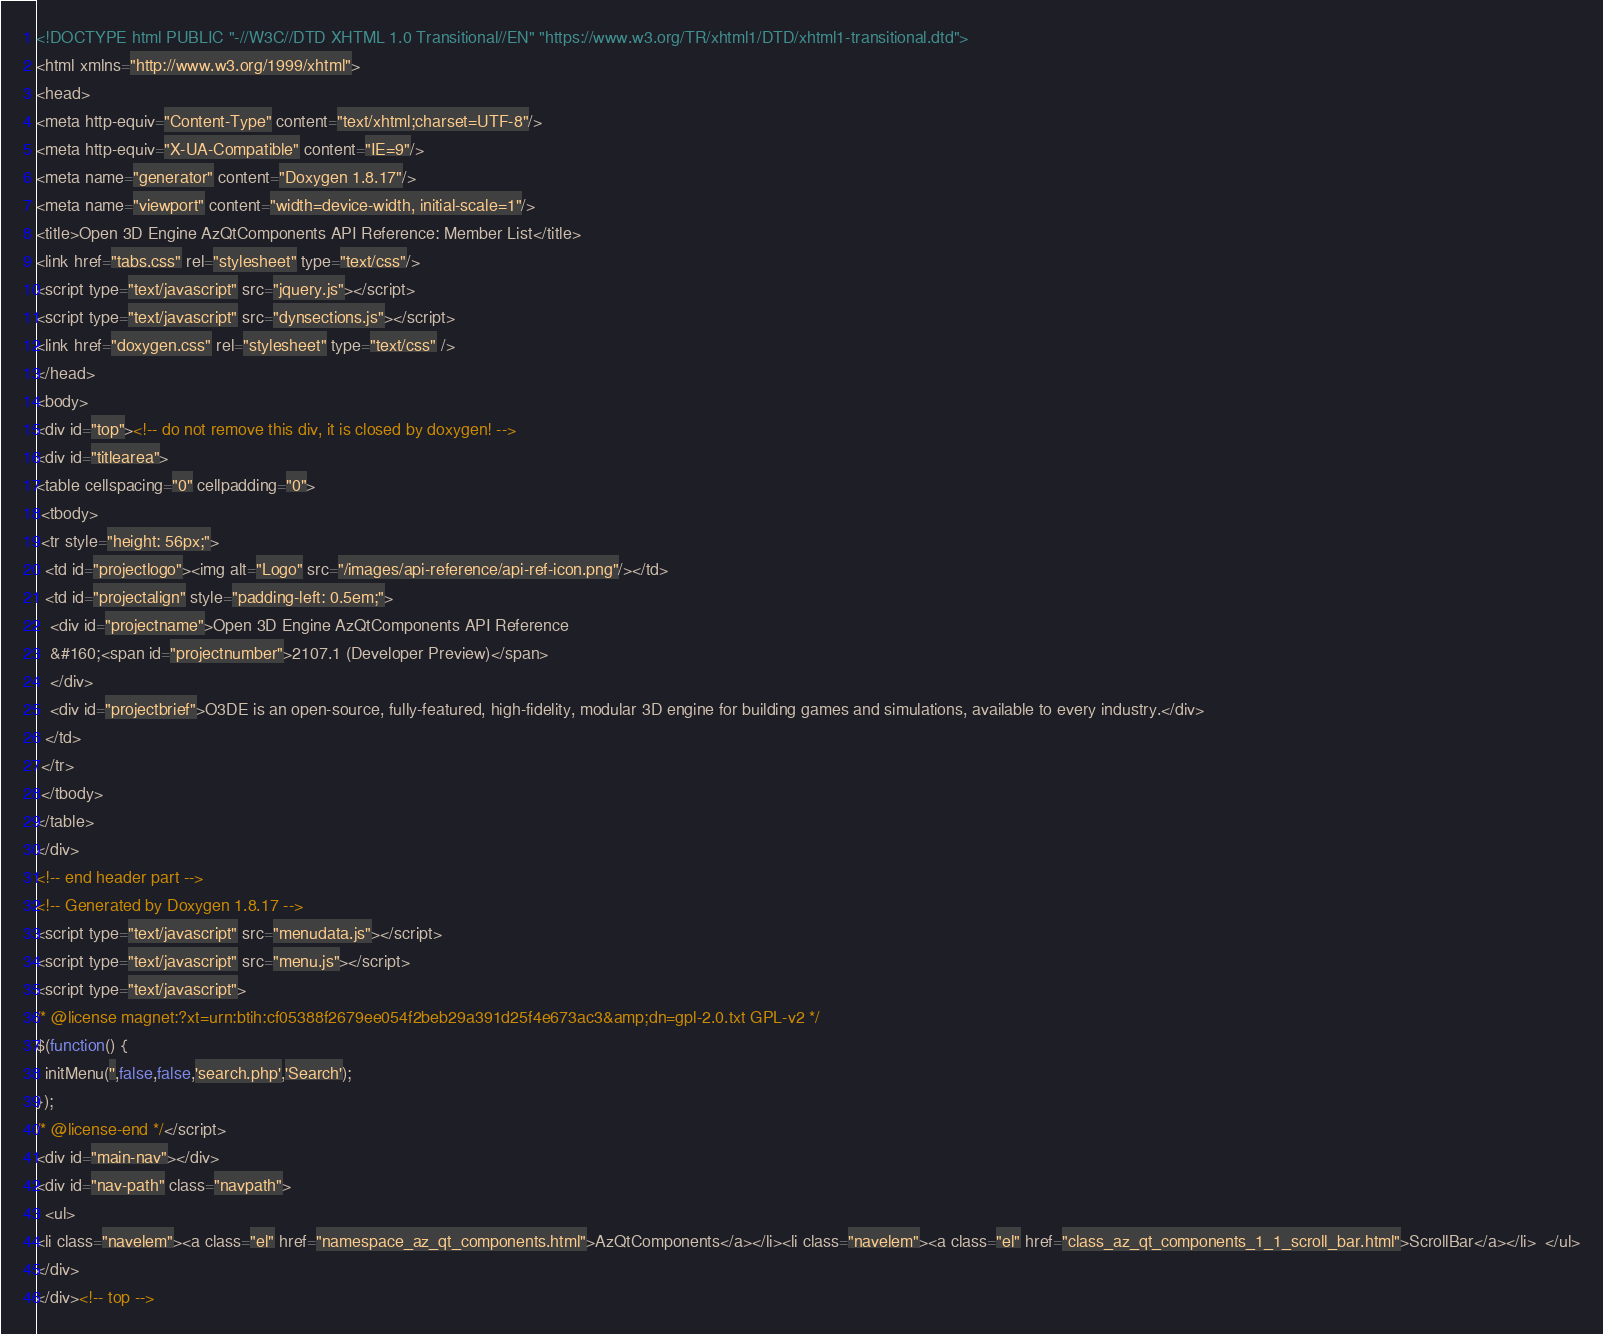<code> <loc_0><loc_0><loc_500><loc_500><_HTML_><!DOCTYPE html PUBLIC "-//W3C//DTD XHTML 1.0 Transitional//EN" "https://www.w3.org/TR/xhtml1/DTD/xhtml1-transitional.dtd">
<html xmlns="http://www.w3.org/1999/xhtml">
<head>
<meta http-equiv="Content-Type" content="text/xhtml;charset=UTF-8"/>
<meta http-equiv="X-UA-Compatible" content="IE=9"/>
<meta name="generator" content="Doxygen 1.8.17"/>
<meta name="viewport" content="width=device-width, initial-scale=1"/>
<title>Open 3D Engine AzQtComponents API Reference: Member List</title>
<link href="tabs.css" rel="stylesheet" type="text/css"/>
<script type="text/javascript" src="jquery.js"></script>
<script type="text/javascript" src="dynsections.js"></script>
<link href="doxygen.css" rel="stylesheet" type="text/css" />
</head>
<body>
<div id="top"><!-- do not remove this div, it is closed by doxygen! -->
<div id="titlearea">
<table cellspacing="0" cellpadding="0">
 <tbody>
 <tr style="height: 56px;">
  <td id="projectlogo"><img alt="Logo" src="/images/api-reference/api-ref-icon.png"/></td>
  <td id="projectalign" style="padding-left: 0.5em;">
   <div id="projectname">Open 3D Engine AzQtComponents API Reference
   &#160;<span id="projectnumber">2107.1 (Developer Preview)</span>
   </div>
   <div id="projectbrief">O3DE is an open-source, fully-featured, high-fidelity, modular 3D engine for building games and simulations, available to every industry.</div>
  </td>
 </tr>
 </tbody>
</table>
</div>
<!-- end header part -->
<!-- Generated by Doxygen 1.8.17 -->
<script type="text/javascript" src="menudata.js"></script>
<script type="text/javascript" src="menu.js"></script>
<script type="text/javascript">
/* @license magnet:?xt=urn:btih:cf05388f2679ee054f2beb29a391d25f4e673ac3&amp;dn=gpl-2.0.txt GPL-v2 */
$(function() {
  initMenu('',false,false,'search.php','Search');
});
/* @license-end */</script>
<div id="main-nav"></div>
<div id="nav-path" class="navpath">
  <ul>
<li class="navelem"><a class="el" href="namespace_az_qt_components.html">AzQtComponents</a></li><li class="navelem"><a class="el" href="class_az_qt_components_1_1_scroll_bar.html">ScrollBar</a></li>  </ul>
</div>
</div><!-- top --></code> 